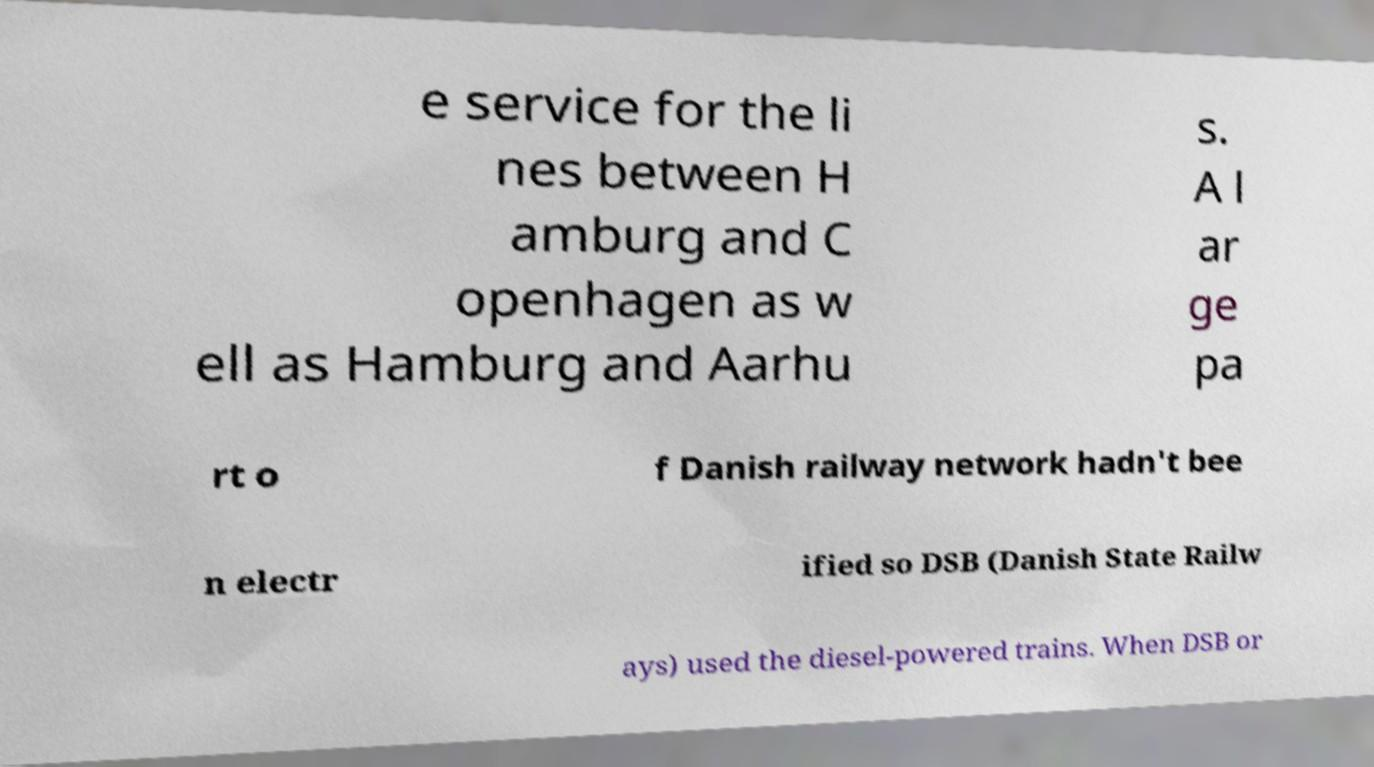Could you assist in decoding the text presented in this image and type it out clearly? e service for the li nes between H amburg and C openhagen as w ell as Hamburg and Aarhu s. A l ar ge pa rt o f Danish railway network hadn't bee n electr ified so DSB (Danish State Railw ays) used the diesel-powered trains. When DSB or 